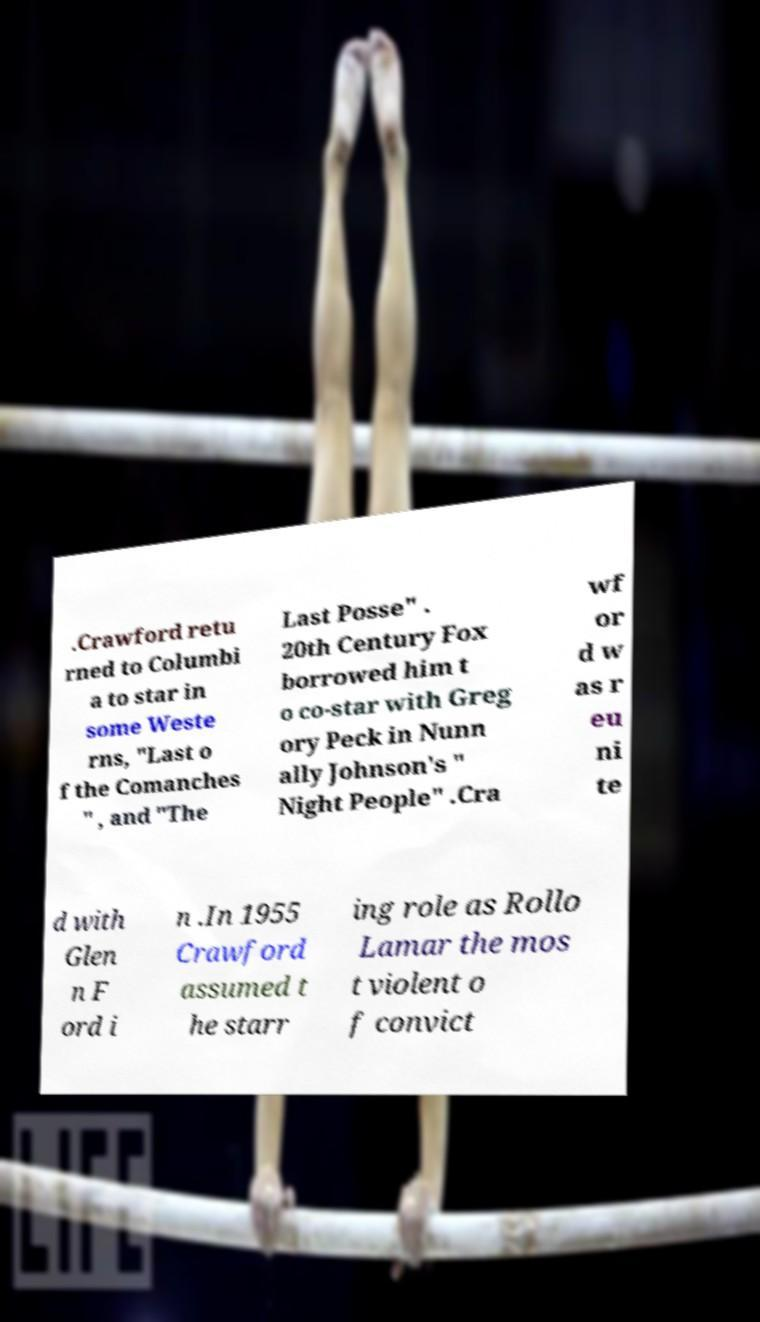Can you read and provide the text displayed in the image?This photo seems to have some interesting text. Can you extract and type it out for me? .Crawford retu rned to Columbi a to star in some Weste rns, "Last o f the Comanches " , and "The Last Posse" . 20th Century Fox borrowed him t o co-star with Greg ory Peck in Nunn ally Johnson's " Night People" .Cra wf or d w as r eu ni te d with Glen n F ord i n .In 1955 Crawford assumed t he starr ing role as Rollo Lamar the mos t violent o f convict 